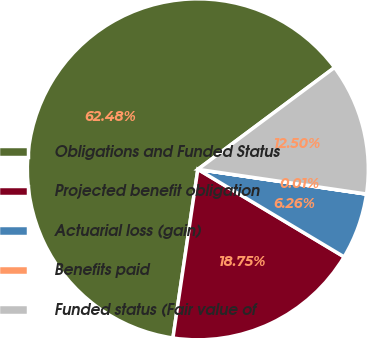Convert chart to OTSL. <chart><loc_0><loc_0><loc_500><loc_500><pie_chart><fcel>Obligations and Funded Status<fcel>Projected benefit obligation<fcel>Actuarial loss (gain)<fcel>Benefits paid<fcel>Funded status (Fair value of<nl><fcel>62.47%<fcel>18.75%<fcel>6.26%<fcel>0.01%<fcel>12.5%<nl></chart> 